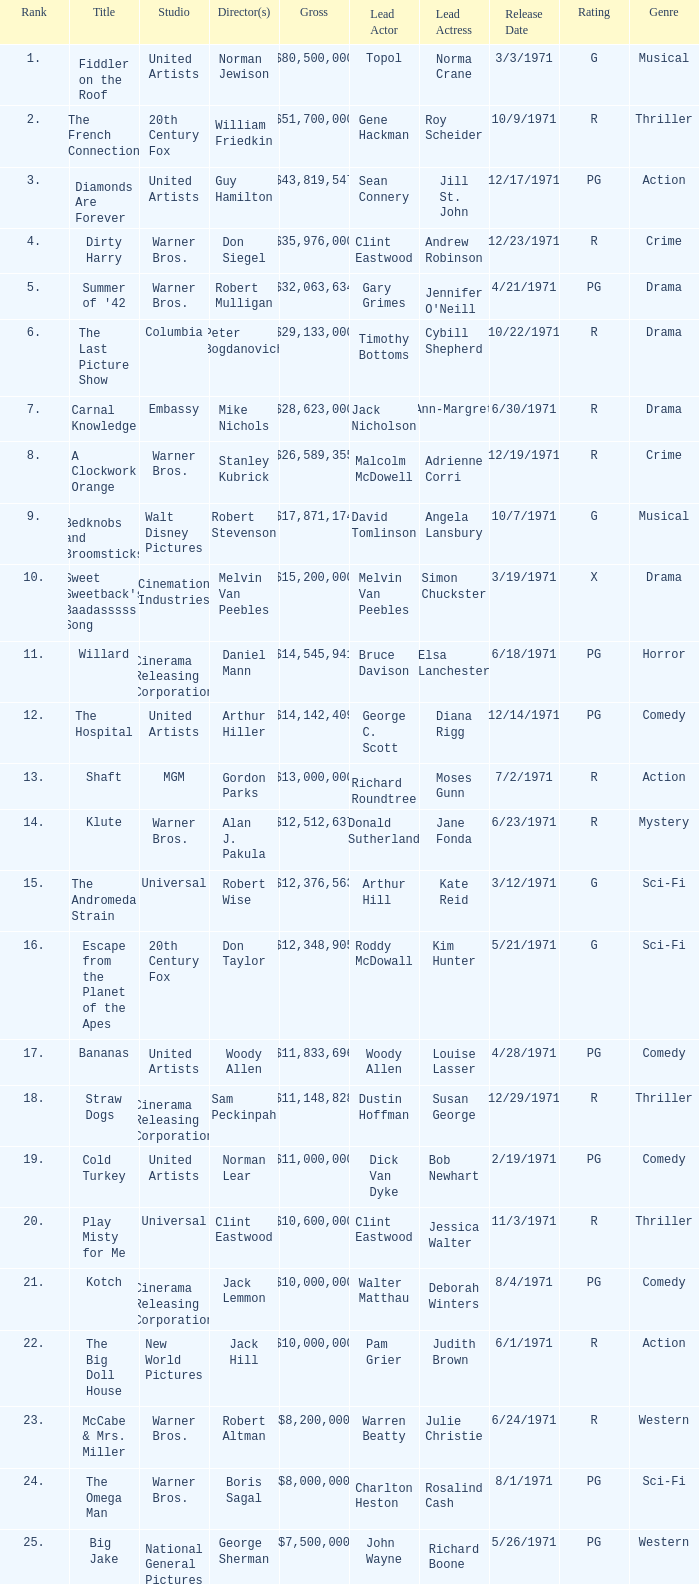What is the rank of The Big Doll House? 22.0. 